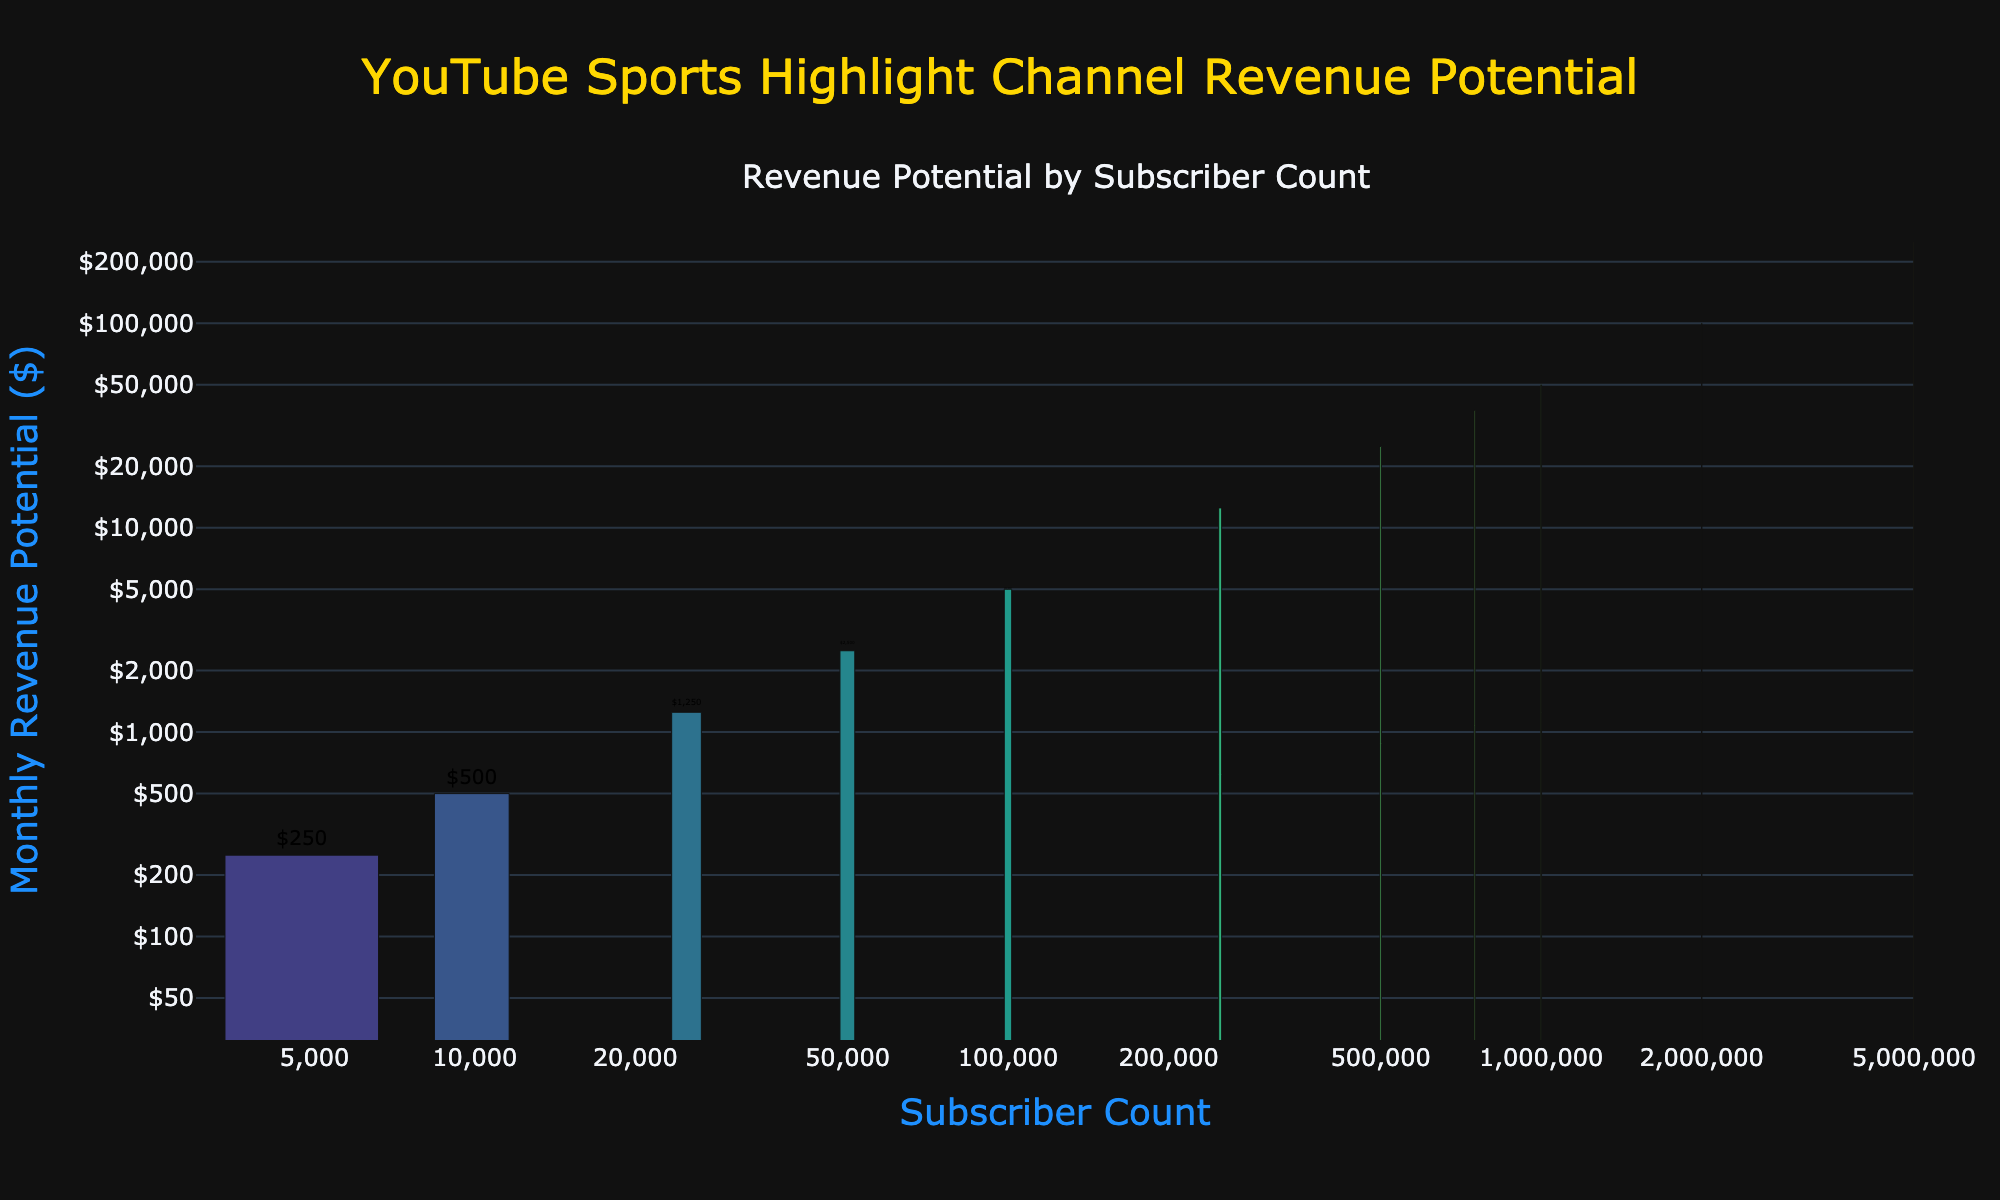What is the monthly revenue potential for a channel with 100,000 subscribers? Look up the corresponding bar for 100,000 subscribers on the x-axis, then read the y-axis value or the text label above the bar which indicates the revenue potential.
Answer: $5,000 Which subscriber count has a higher revenue potential: 50,000 or 250,000? Compare the heights or the y-axis values of the bars corresponding to 50,000 and 250,000 subscribers. The bar for 250,000 subscribers has a higher revenue potential.
Answer: 250,000 What is the difference in monthly revenue potential between channels with 500,000 and 1,000,000 subscribers? Look at the y-axis values for 500,000 subscribers ($25,000) and 1,000,000 subscribers ($50,000), then subtract the lower value from the higher one.
Answer: $25,000 How many times higher is the revenue potential of a channel with 1,000,000 subscribers compared to a channel with 100,000 subscribers? Identify the revenue potentials from the y-axis labels or text labels: $50,000 for 1,000,000 subscribers and $5,000 for 100,000 subscribers. Divide $50,000 by $5,000 to get the ratio.
Answer: 10 times What subscriber count corresponds to a monthly revenue potential of $125,000? Locate the $125,000 revenue potential on the y-axis and trace horizontally to find the corresponding subscriber count.
Answer: 2,000,000 subscribers What is the average monthly revenue potential for channels with 10,000, 50,000, and 100,000 subscribers? Identify the revenue potentials: $500 for 10,000, $2,500 for 50,000, and $5,000 for 100,000 subscribers. Sum these values and divide by 3: ($500 + $2,500 + $5,000) / 3 = $8,000 / 3.
Answer: $2,667 If a channel with 500,000 subscribers doubles its subscriber count, what will be its expected monthly revenue potential? Identify the revenue potential for 500,000 subscribers ($25,000) and 1,000,000 subscribers ($50,000). Doubling 500,000 subscribers to 1,000,000 matches the revenue potential of $50,000.
Answer: $50,000 Which color does the bar representing 5,000,000 subscribers have compared to the others? Observe the gradient scale applied to the bar colors. The highest revenue potential bars (including 5,000,000 subscribers) will be the darkest due to the logarithmic scale of the color.
Answer: Darkest shade What is the incremental revenue gain when moving from 1,000,000 to 2,000,000 subscribers? Identify the revenue for 1,000,000 subscribers ($50,000) and for 2,000,000 subscribers ($100,000). Subtract $50,000 from $100,000.
Answer: $50,000 